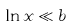<formula> <loc_0><loc_0><loc_500><loc_500>\ln x \ll b</formula> 